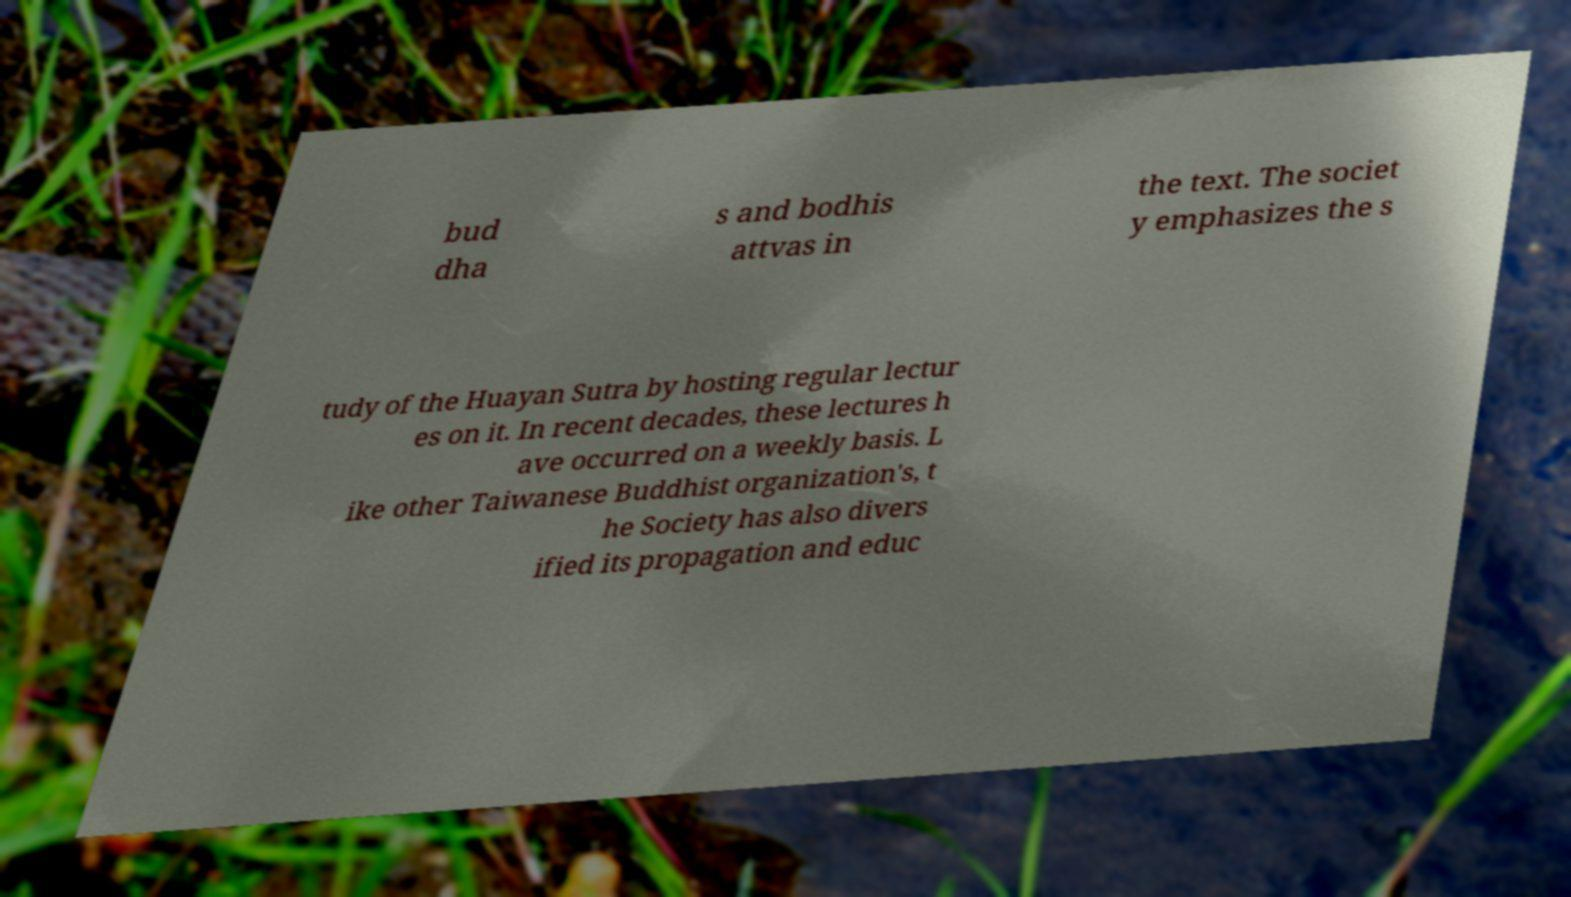Can you accurately transcribe the text from the provided image for me? bud dha s and bodhis attvas in the text. The societ y emphasizes the s tudy of the Huayan Sutra by hosting regular lectur es on it. In recent decades, these lectures h ave occurred on a weekly basis. L ike other Taiwanese Buddhist organization's, t he Society has also divers ified its propagation and educ 